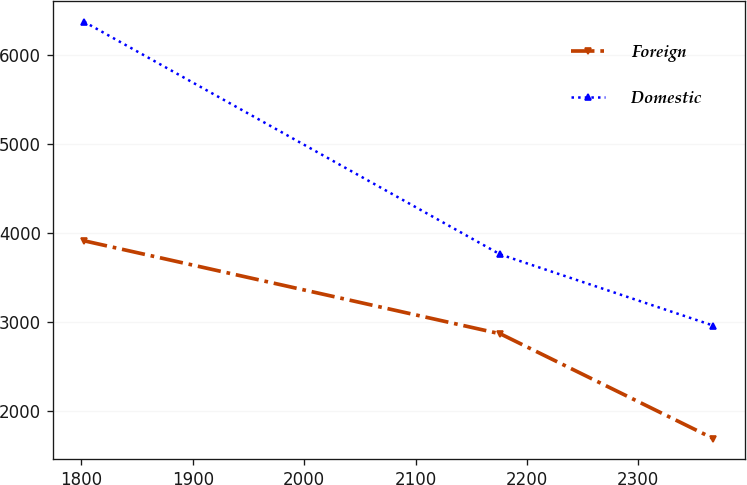<chart> <loc_0><loc_0><loc_500><loc_500><line_chart><ecel><fcel>Foreign<fcel>Domestic<nl><fcel>1802.45<fcel>3912.73<fcel>6372.16<nl><fcel>2176.16<fcel>2868.13<fcel>3759.11<nl><fcel>2367.44<fcel>1691.8<fcel>2959.84<nl></chart> 